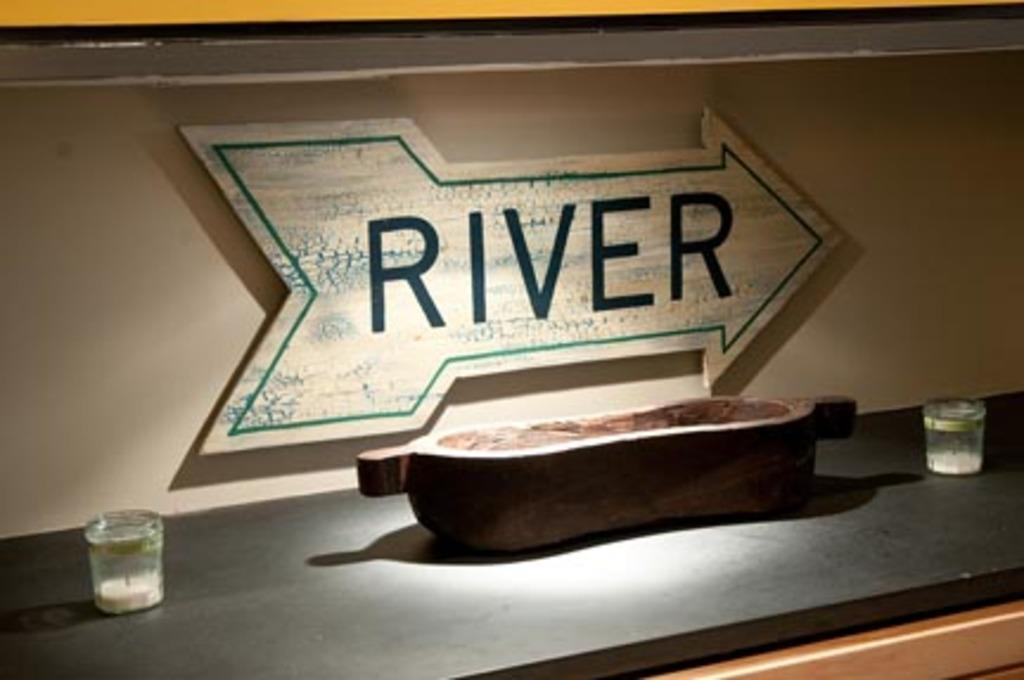<image>
Create a compact narrative representing the image presented. A kitchen countertop with a bowl, two candles, and an arrow sign with the word "river" painted on it. 